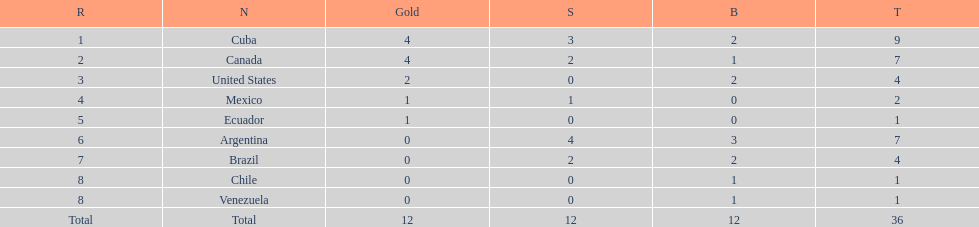Which nation won gold but did not win silver? United States. 